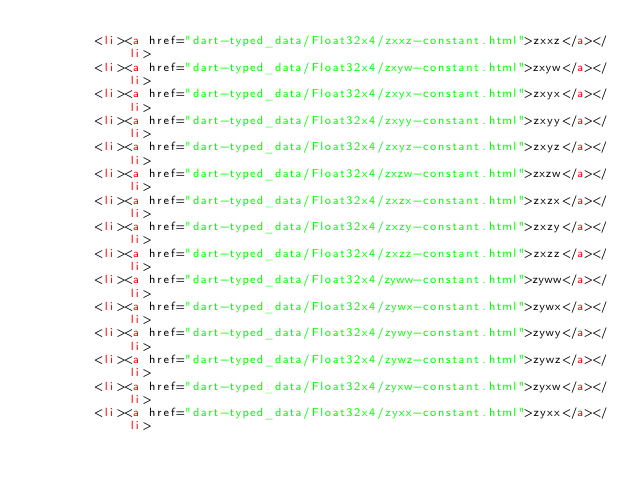<code> <loc_0><loc_0><loc_500><loc_500><_HTML_>        <li><a href="dart-typed_data/Float32x4/zxxz-constant.html">zxxz</a></li>
        <li><a href="dart-typed_data/Float32x4/zxyw-constant.html">zxyw</a></li>
        <li><a href="dart-typed_data/Float32x4/zxyx-constant.html">zxyx</a></li>
        <li><a href="dart-typed_data/Float32x4/zxyy-constant.html">zxyy</a></li>
        <li><a href="dart-typed_data/Float32x4/zxyz-constant.html">zxyz</a></li>
        <li><a href="dart-typed_data/Float32x4/zxzw-constant.html">zxzw</a></li>
        <li><a href="dart-typed_data/Float32x4/zxzx-constant.html">zxzx</a></li>
        <li><a href="dart-typed_data/Float32x4/zxzy-constant.html">zxzy</a></li>
        <li><a href="dart-typed_data/Float32x4/zxzz-constant.html">zxzz</a></li>
        <li><a href="dart-typed_data/Float32x4/zyww-constant.html">zyww</a></li>
        <li><a href="dart-typed_data/Float32x4/zywx-constant.html">zywx</a></li>
        <li><a href="dart-typed_data/Float32x4/zywy-constant.html">zywy</a></li>
        <li><a href="dart-typed_data/Float32x4/zywz-constant.html">zywz</a></li>
        <li><a href="dart-typed_data/Float32x4/zyxw-constant.html">zyxw</a></li>
        <li><a href="dart-typed_data/Float32x4/zyxx-constant.html">zyxx</a></li></code> 